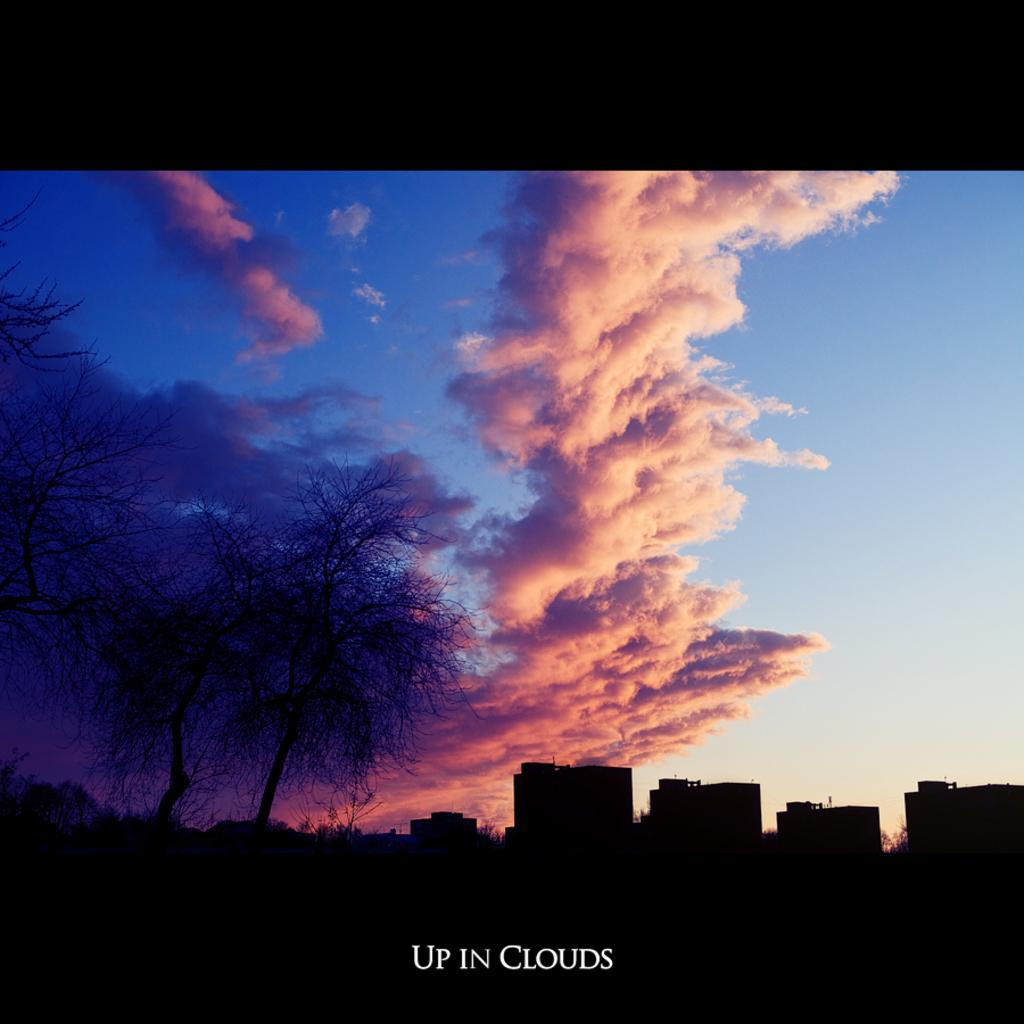What type of structures can be seen in the image? There are buildings in the image. What other natural elements are present in the image? There are trees in the image. What is visible at the top of the image? The sky is visible at the top of the image. What can be observed in the sky? There are clouds in the sky. What flavor of scissors can be seen in the image? There are no scissors present in the image, so it is not possible to determine their flavor. 